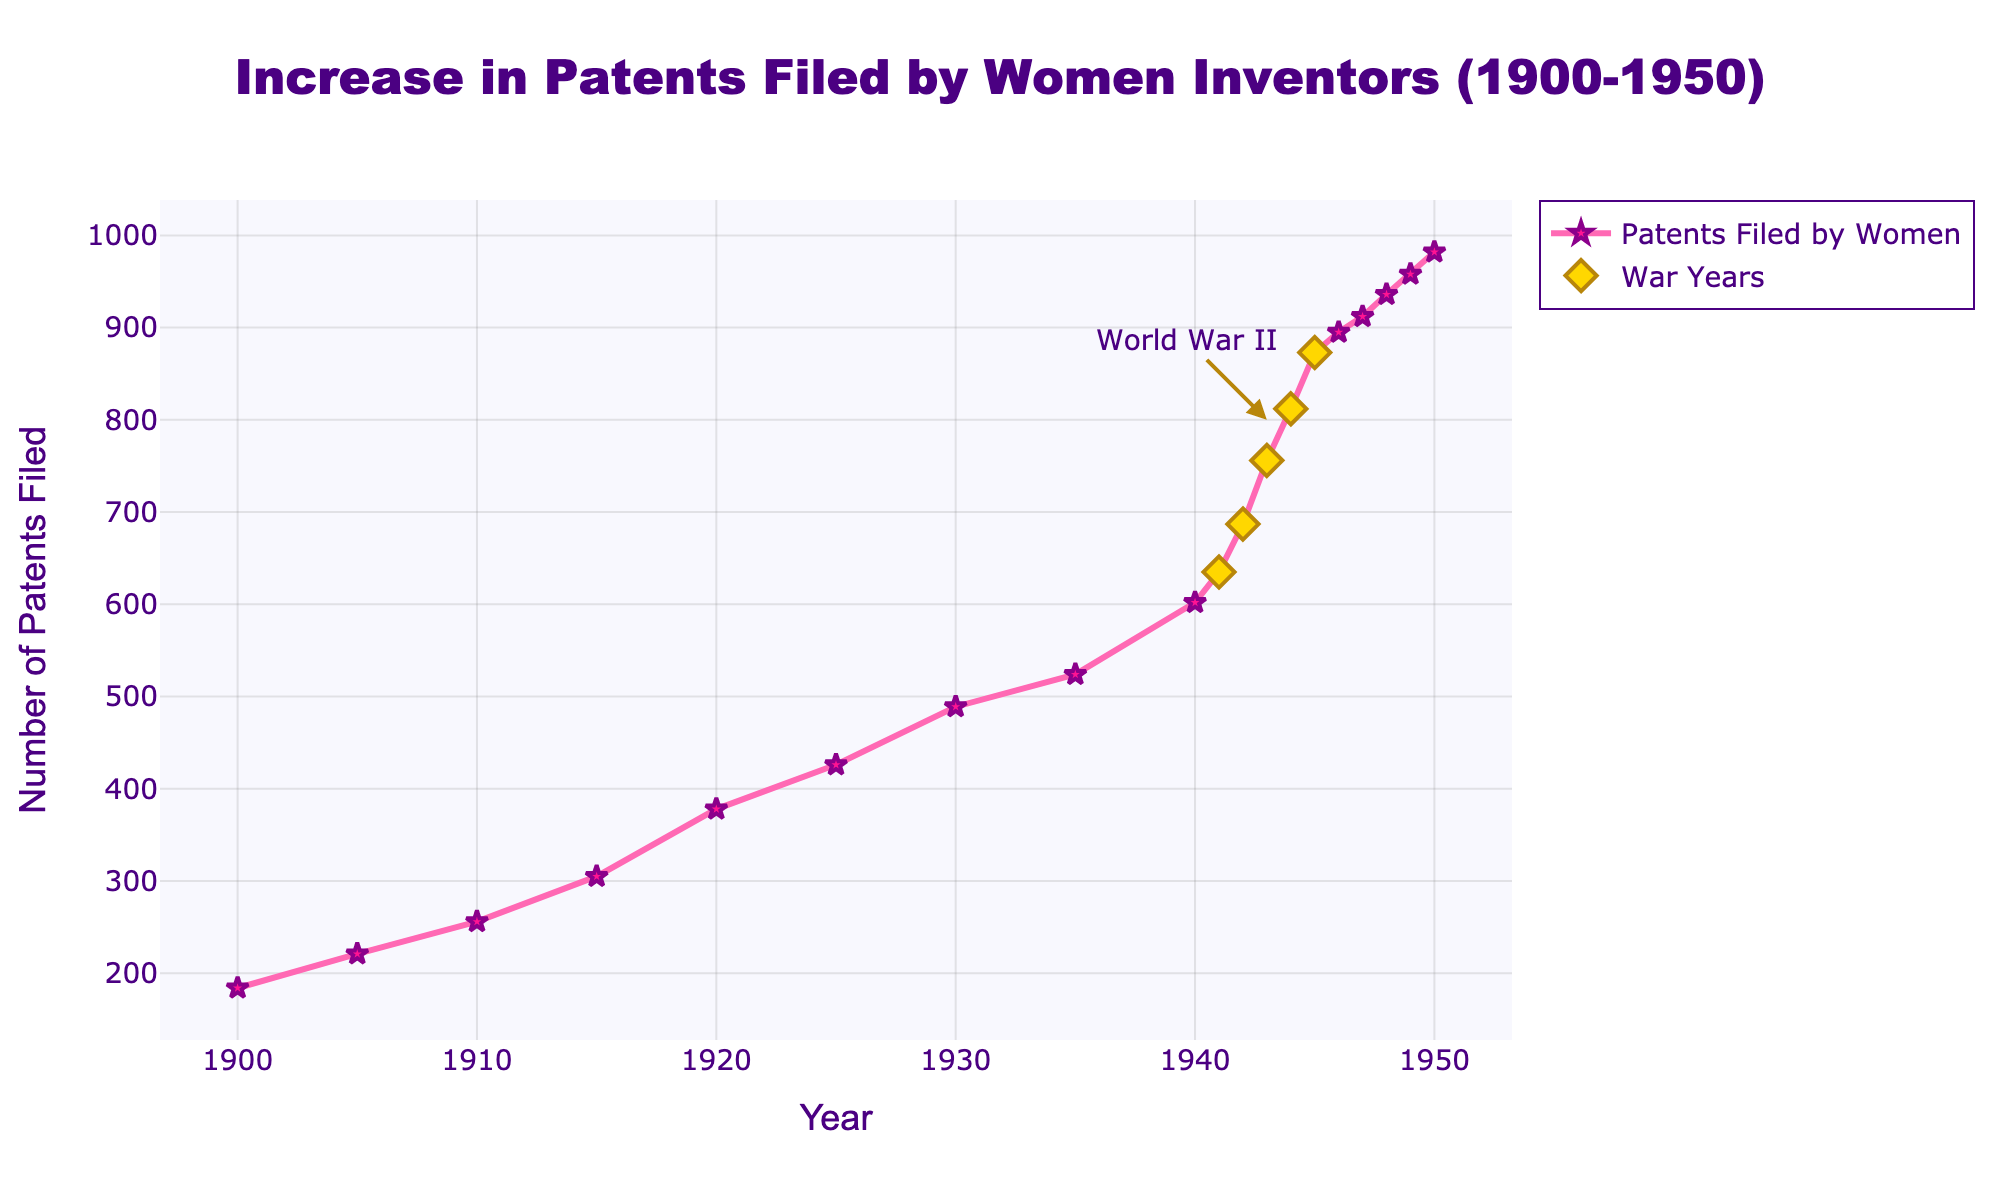What is the general trend in the number of patents filed by women from 1900 to 1950? The general trend shows a steady increase in the number of patents filed by women from 1900 to 1950, as the line consistently rises without any significant drops.
Answer: Steady increase How did the number of patents filed by women change during World War II years? During the World War II years (1941-1945), the number of patents filed by women increased significantly. The points for the war years are highlighted, showing a sharp rise from 635 in 1941 to 873 in 1945.
Answer: Sharp increase Which year during World War II saw the highest number of patents filed by women? Looking at the highlighted points, 1945 has the highest number of patents filed by women during World War II, with 873 patents.
Answer: 1945 How many more patents were filed in 1950 compared to 1900? To find this, subtract the number of patents in 1900 from the number in 1950: 982 - 184 = 798.
Answer: 798 Compare the growth in patents filed between 1935 and 1945. The number of patents in 1935 was 524, and in 1945 it was 873. The growth can be calculated by subtracting the 1935 value from the 1945 value: 873 - 524 = 349.
Answer: 349 Which years saw the most noticeable increase within the World War II period? From the highlighted points, the increase from 1942 to 1943 (687 to 756) and from 1943 to 1944 (756 to 812) are the most noticeable.
Answer: 1942 to 1943, 1943 to 1944 What visual cue indicates the World War II years on the plot? The World War II years are indicated by yellow diamond markers on the plot and an annotation labeled "World War II" near the peak in 1943.
Answer: Yellow diamond markers and annotation What is the average number of patents filed by women from 1941 to 1945? Sum the patents from 1941 to 1945 (635 + 687 + 756 + 812 + 873 = 3763) and divide by the number of years (5): 3763 / 5 = 752.6.
Answer: 752.6 Is there any year where the number of patents filed by women decreased compared to the previous year? There is no year in the given data where the number of patents filed by women decreased compared to the previous year; all values show an increase.
Answer: No 